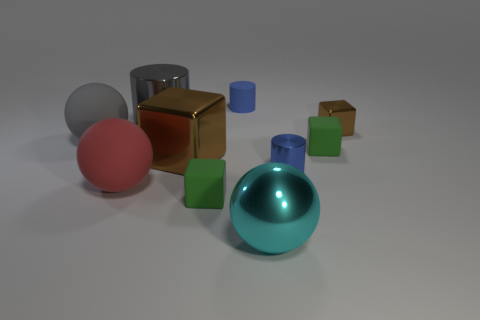How many things are either big gray metal cylinders or small green rubber cubes?
Offer a very short reply. 3. How many other things are there of the same size as the gray ball?
Provide a succinct answer. 4. How many small things are right of the cyan ball and in front of the large gray rubber thing?
Provide a short and direct response. 2. There is a object to the left of the big red object; is its size the same as the matte thing that is behind the small brown cube?
Make the answer very short. No. What size is the green matte object that is to the left of the tiny blue metallic object?
Your answer should be compact. Small. What number of things are either matte things behind the small blue shiny object or things that are right of the big gray cylinder?
Offer a very short reply. 8. Is there any other thing that is the same color as the small metallic cylinder?
Give a very brief answer. Yes. Is the number of large cubes that are on the right side of the blue matte object the same as the number of red rubber things that are to the left of the big gray metal object?
Your answer should be very brief. No. Is the number of small blue cylinders behind the tiny brown metallic cube greater than the number of blue metal spheres?
Provide a succinct answer. Yes. What number of objects are either brown metal blocks in front of the large gray sphere or small blue matte cylinders?
Offer a very short reply. 2. 